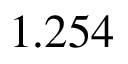Convert formula to latex. <formula><loc_0><loc_0><loc_500><loc_500>1 . 2 5 4</formula> 